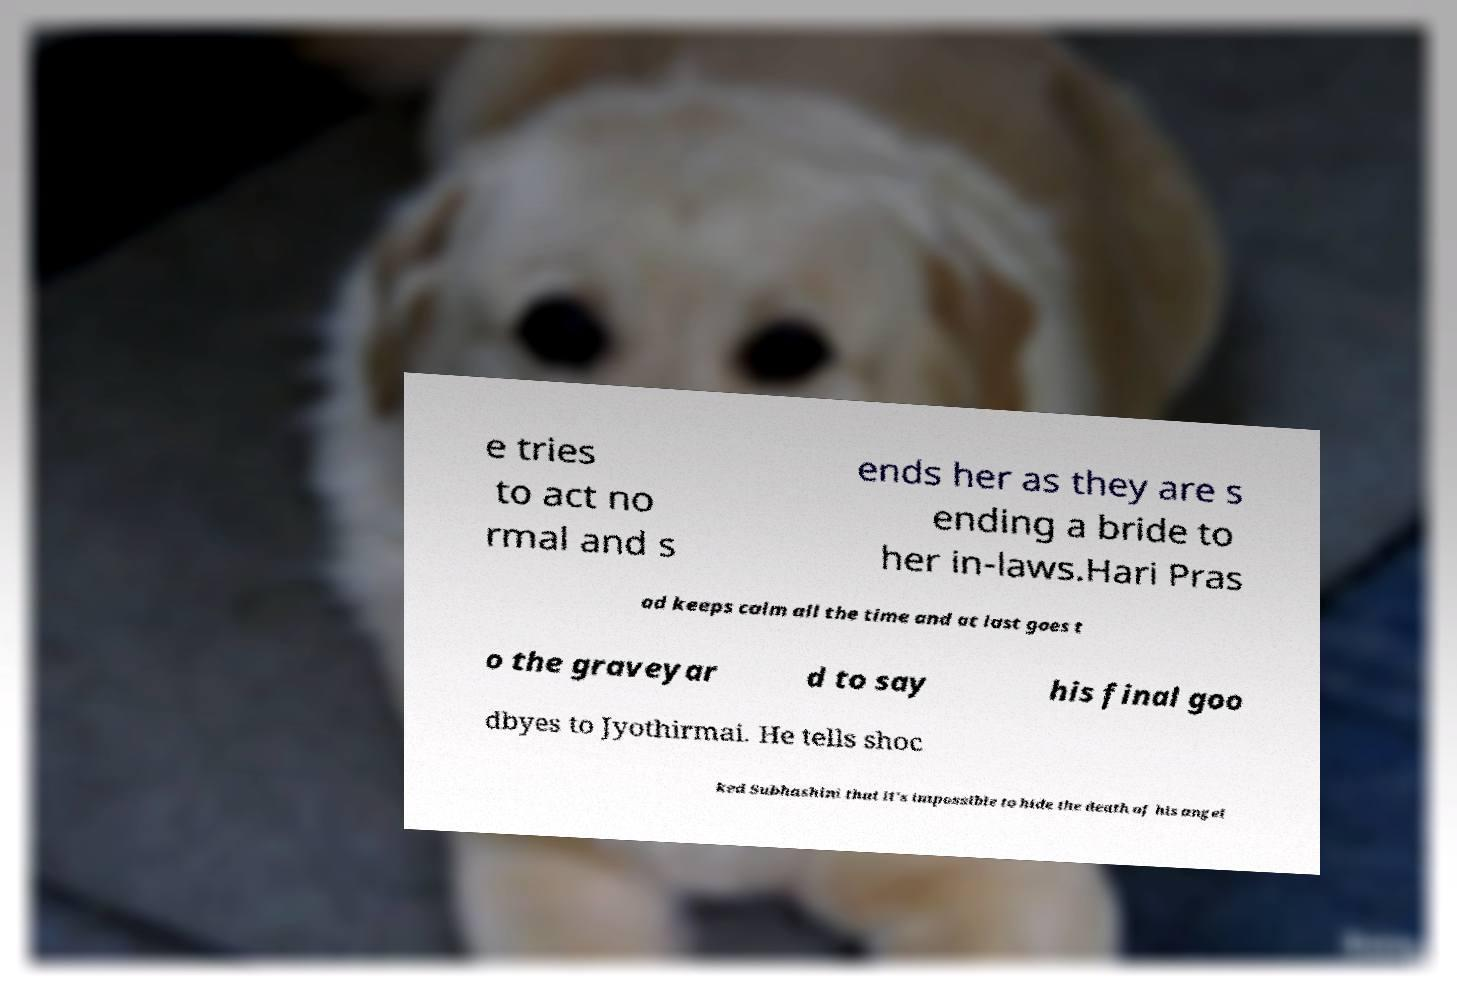Can you read and provide the text displayed in the image?This photo seems to have some interesting text. Can you extract and type it out for me? e tries to act no rmal and s ends her as they are s ending a bride to her in-laws.Hari Pras ad keeps calm all the time and at last goes t o the graveyar d to say his final goo dbyes to Jyothirmai. He tells shoc ked Subhashini that it's impossible to hide the death of his angel 